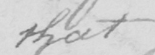Please transcribe the handwritten text in this image. that 